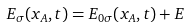Convert formula to latex. <formula><loc_0><loc_0><loc_500><loc_500>E _ { \sigma } ( x _ { A } , t ) = E _ { 0 \sigma } ( x _ { A } , t ) + E</formula> 